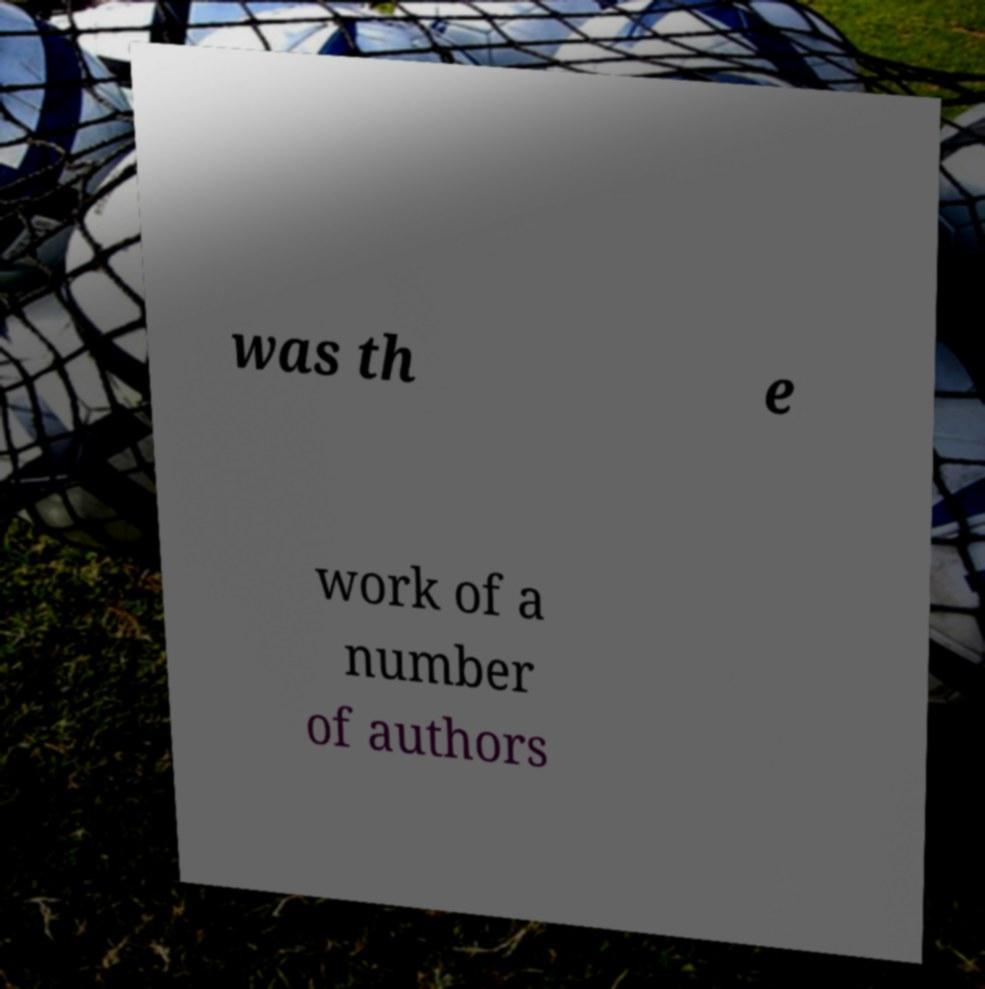I need the written content from this picture converted into text. Can you do that? was th e work of a number of authors 